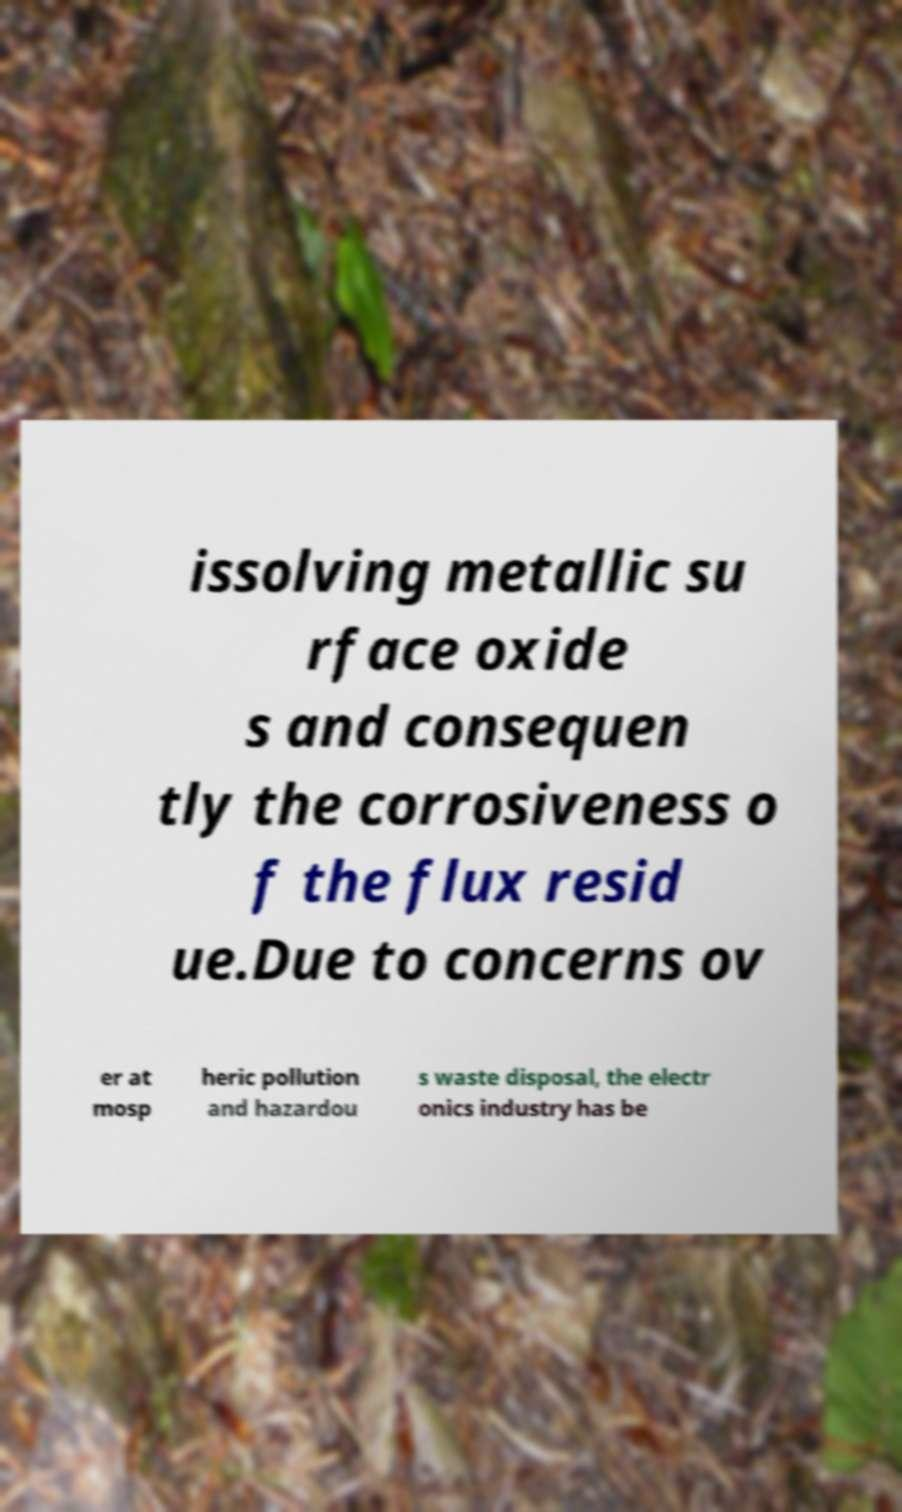Could you assist in decoding the text presented in this image and type it out clearly? issolving metallic su rface oxide s and consequen tly the corrosiveness o f the flux resid ue.Due to concerns ov er at mosp heric pollution and hazardou s waste disposal, the electr onics industry has be 